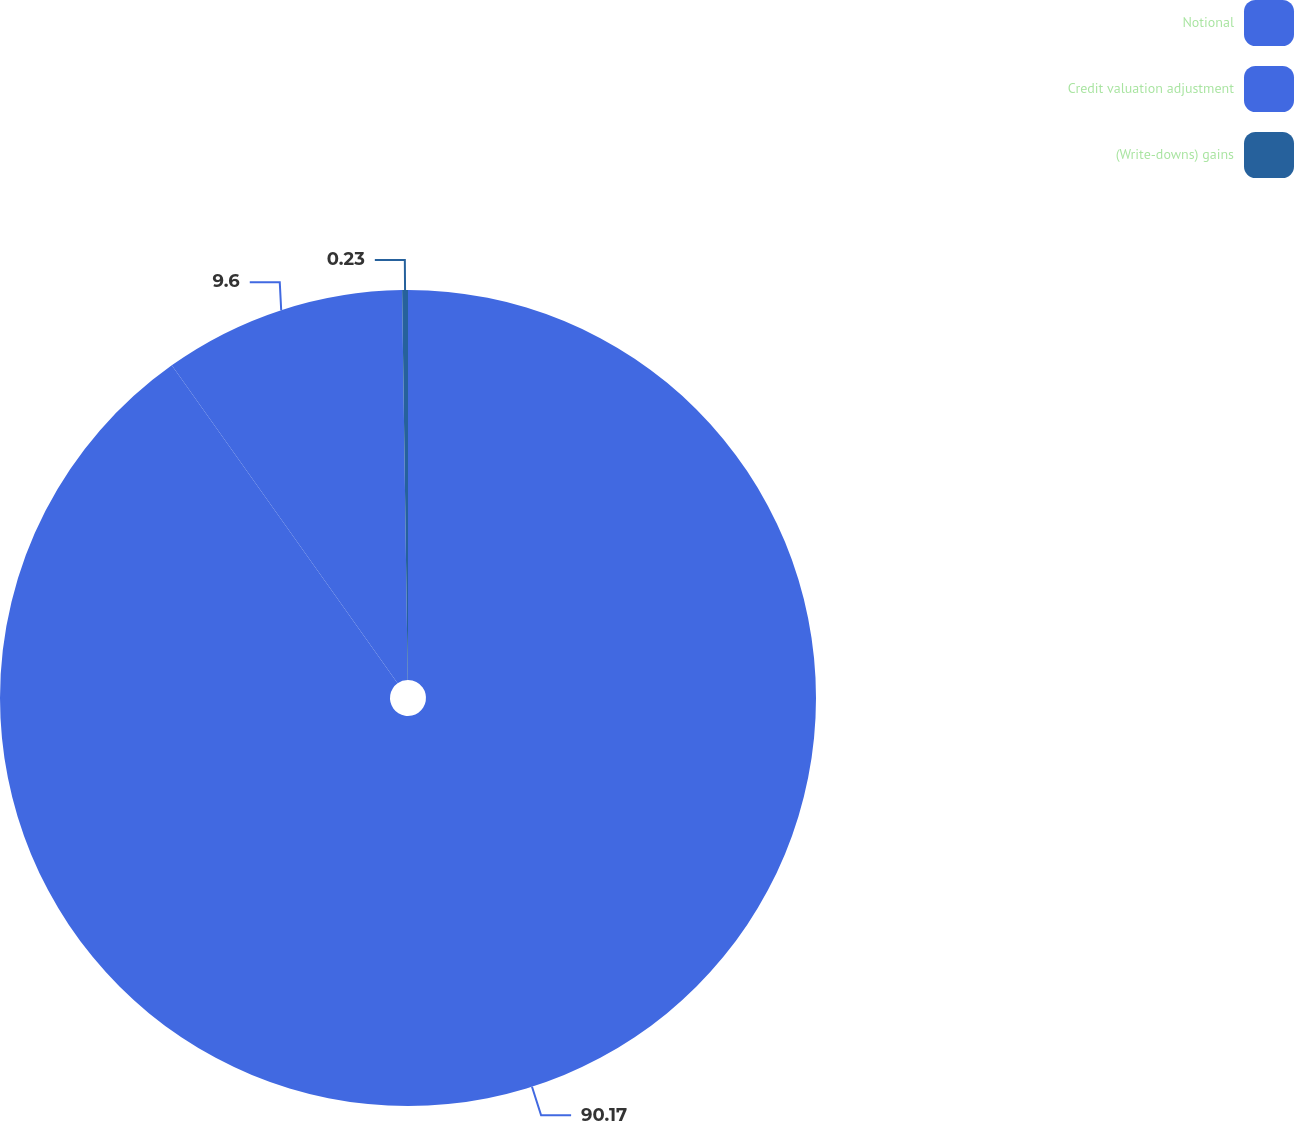<chart> <loc_0><loc_0><loc_500><loc_500><pie_chart><fcel>Notional<fcel>Credit valuation adjustment<fcel>(Write-downs) gains<nl><fcel>90.18%<fcel>9.6%<fcel>0.23%<nl></chart> 